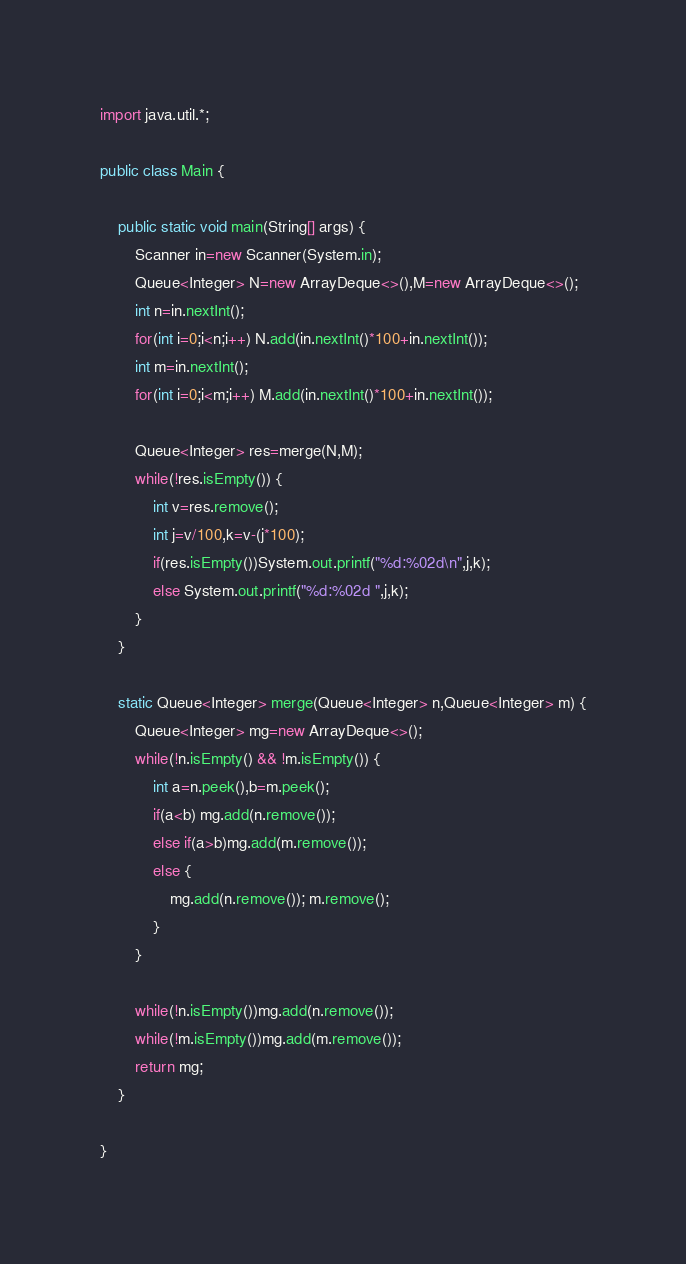Convert code to text. <code><loc_0><loc_0><loc_500><loc_500><_Java_>import java.util.*;

public class Main {

	public static void main(String[] args) {
		Scanner in=new Scanner(System.in);
		Queue<Integer> N=new ArrayDeque<>(),M=new ArrayDeque<>();
		int n=in.nextInt();
		for(int i=0;i<n;i++) N.add(in.nextInt()*100+in.nextInt());
		int m=in.nextInt();
		for(int i=0;i<m;i++) M.add(in.nextInt()*100+in.nextInt());
		
		Queue<Integer> res=merge(N,M);
		while(!res.isEmpty()) {
			int v=res.remove();
			int j=v/100,k=v-(j*100);
			if(res.isEmpty())System.out.printf("%d:%02d\n",j,k);
			else System.out.printf("%d:%02d ",j,k);
		}
	}
	
	static Queue<Integer> merge(Queue<Integer> n,Queue<Integer> m) {
		Queue<Integer> mg=new ArrayDeque<>();
		while(!n.isEmpty() && !m.isEmpty()) {
			int a=n.peek(),b=m.peek();
			if(a<b) mg.add(n.remove());
			else if(a>b)mg.add(m.remove());
			else {
				mg.add(n.remove()); m.remove();
			}
		}
		
		while(!n.isEmpty())mg.add(n.remove());
		while(!m.isEmpty())mg.add(m.remove());
		return mg;
	}

}

</code> 